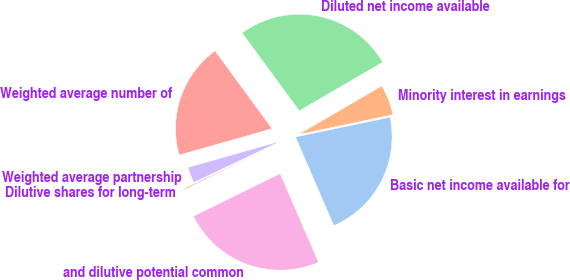<chart> <loc_0><loc_0><loc_500><loc_500><pie_chart><fcel>Basic net income available for<fcel>Minority interest in earnings<fcel>Diluted net income available<fcel>Weighted average number of<fcel>Weighted average partnership<fcel>Dilutive shares for long-term<fcel>and dilutive potential common<nl><fcel>21.78%<fcel>5.11%<fcel>26.68%<fcel>19.33%<fcel>2.66%<fcel>0.21%<fcel>24.23%<nl></chart> 